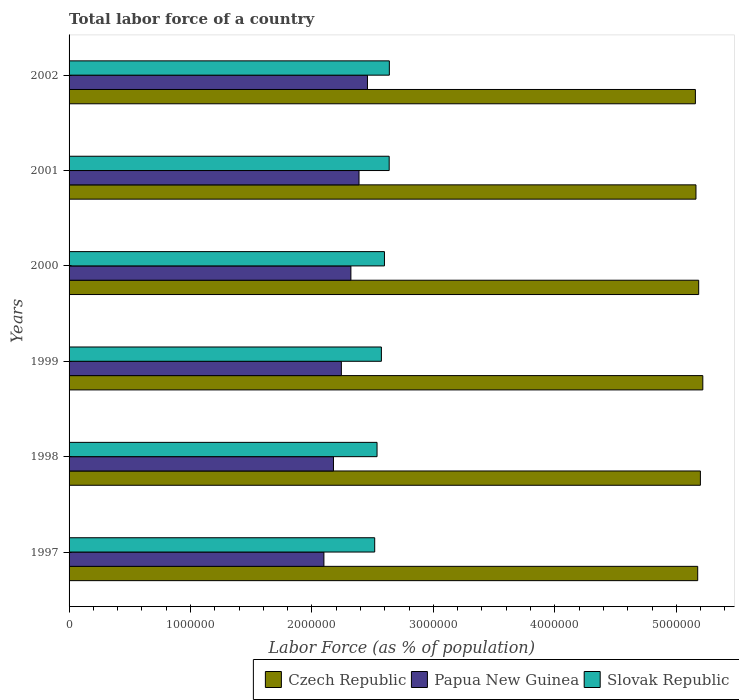How many groups of bars are there?
Offer a very short reply. 6. Are the number of bars per tick equal to the number of legend labels?
Your answer should be compact. Yes. How many bars are there on the 5th tick from the top?
Your answer should be very brief. 3. What is the label of the 1st group of bars from the top?
Give a very brief answer. 2002. What is the percentage of labor force in Czech Republic in 1997?
Provide a succinct answer. 5.18e+06. Across all years, what is the maximum percentage of labor force in Czech Republic?
Give a very brief answer. 5.22e+06. Across all years, what is the minimum percentage of labor force in Slovak Republic?
Give a very brief answer. 2.52e+06. In which year was the percentage of labor force in Papua New Guinea maximum?
Provide a succinct answer. 2002. What is the total percentage of labor force in Slovak Republic in the graph?
Offer a very short reply. 1.55e+07. What is the difference between the percentage of labor force in Slovak Republic in 2000 and that in 2001?
Make the answer very short. -3.89e+04. What is the difference between the percentage of labor force in Czech Republic in 1999 and the percentage of labor force in Papua New Guinea in 2002?
Your answer should be compact. 2.76e+06. What is the average percentage of labor force in Slovak Republic per year?
Make the answer very short. 2.58e+06. In the year 2001, what is the difference between the percentage of labor force in Papua New Guinea and percentage of labor force in Czech Republic?
Provide a short and direct response. -2.77e+06. What is the ratio of the percentage of labor force in Papua New Guinea in 1999 to that in 2001?
Make the answer very short. 0.94. Is the difference between the percentage of labor force in Papua New Guinea in 1997 and 2001 greater than the difference between the percentage of labor force in Czech Republic in 1997 and 2001?
Provide a short and direct response. No. What is the difference between the highest and the second highest percentage of labor force in Czech Republic?
Keep it short and to the point. 1.98e+04. What is the difference between the highest and the lowest percentage of labor force in Slovak Republic?
Make the answer very short. 1.21e+05. In how many years, is the percentage of labor force in Papua New Guinea greater than the average percentage of labor force in Papua New Guinea taken over all years?
Keep it short and to the point. 3. What does the 3rd bar from the top in 2001 represents?
Provide a succinct answer. Czech Republic. What does the 3rd bar from the bottom in 2001 represents?
Give a very brief answer. Slovak Republic. Are all the bars in the graph horizontal?
Ensure brevity in your answer.  Yes. Does the graph contain grids?
Your response must be concise. No. Where does the legend appear in the graph?
Keep it short and to the point. Bottom right. How many legend labels are there?
Your answer should be very brief. 3. What is the title of the graph?
Provide a succinct answer. Total labor force of a country. Does "Denmark" appear as one of the legend labels in the graph?
Your response must be concise. No. What is the label or title of the X-axis?
Your answer should be very brief. Labor Force (as % of population). What is the label or title of the Y-axis?
Your answer should be compact. Years. What is the Labor Force (as % of population) in Czech Republic in 1997?
Give a very brief answer. 5.18e+06. What is the Labor Force (as % of population) of Papua New Guinea in 1997?
Ensure brevity in your answer.  2.10e+06. What is the Labor Force (as % of population) of Slovak Republic in 1997?
Ensure brevity in your answer.  2.52e+06. What is the Labor Force (as % of population) of Czech Republic in 1998?
Your answer should be compact. 5.20e+06. What is the Labor Force (as % of population) in Papua New Guinea in 1998?
Your answer should be very brief. 2.18e+06. What is the Labor Force (as % of population) in Slovak Republic in 1998?
Ensure brevity in your answer.  2.54e+06. What is the Labor Force (as % of population) in Czech Republic in 1999?
Ensure brevity in your answer.  5.22e+06. What is the Labor Force (as % of population) of Papua New Guinea in 1999?
Make the answer very short. 2.24e+06. What is the Labor Force (as % of population) of Slovak Republic in 1999?
Provide a short and direct response. 2.57e+06. What is the Labor Force (as % of population) of Czech Republic in 2000?
Your response must be concise. 5.18e+06. What is the Labor Force (as % of population) in Papua New Guinea in 2000?
Your answer should be very brief. 2.32e+06. What is the Labor Force (as % of population) in Slovak Republic in 2000?
Your answer should be very brief. 2.60e+06. What is the Labor Force (as % of population) in Czech Republic in 2001?
Keep it short and to the point. 5.16e+06. What is the Labor Force (as % of population) in Papua New Guinea in 2001?
Provide a succinct answer. 2.39e+06. What is the Labor Force (as % of population) of Slovak Republic in 2001?
Offer a very short reply. 2.64e+06. What is the Labor Force (as % of population) in Czech Republic in 2002?
Offer a very short reply. 5.16e+06. What is the Labor Force (as % of population) in Papua New Guinea in 2002?
Offer a very short reply. 2.46e+06. What is the Labor Force (as % of population) in Slovak Republic in 2002?
Give a very brief answer. 2.64e+06. Across all years, what is the maximum Labor Force (as % of population) of Czech Republic?
Your answer should be compact. 5.22e+06. Across all years, what is the maximum Labor Force (as % of population) in Papua New Guinea?
Offer a terse response. 2.46e+06. Across all years, what is the maximum Labor Force (as % of population) in Slovak Republic?
Make the answer very short. 2.64e+06. Across all years, what is the minimum Labor Force (as % of population) of Czech Republic?
Your answer should be compact. 5.16e+06. Across all years, what is the minimum Labor Force (as % of population) in Papua New Guinea?
Offer a very short reply. 2.10e+06. Across all years, what is the minimum Labor Force (as % of population) of Slovak Republic?
Keep it short and to the point. 2.52e+06. What is the total Labor Force (as % of population) in Czech Republic in the graph?
Your response must be concise. 3.11e+07. What is the total Labor Force (as % of population) in Papua New Guinea in the graph?
Ensure brevity in your answer.  1.37e+07. What is the total Labor Force (as % of population) of Slovak Republic in the graph?
Offer a terse response. 1.55e+07. What is the difference between the Labor Force (as % of population) of Czech Republic in 1997 and that in 1998?
Your answer should be very brief. -2.22e+04. What is the difference between the Labor Force (as % of population) of Papua New Guinea in 1997 and that in 1998?
Provide a succinct answer. -7.87e+04. What is the difference between the Labor Force (as % of population) in Slovak Republic in 1997 and that in 1998?
Provide a short and direct response. -1.93e+04. What is the difference between the Labor Force (as % of population) in Czech Republic in 1997 and that in 1999?
Offer a terse response. -4.21e+04. What is the difference between the Labor Force (as % of population) of Papua New Guinea in 1997 and that in 1999?
Provide a short and direct response. -1.44e+05. What is the difference between the Labor Force (as % of population) of Slovak Republic in 1997 and that in 1999?
Provide a short and direct response. -5.51e+04. What is the difference between the Labor Force (as % of population) in Czech Republic in 1997 and that in 2000?
Ensure brevity in your answer.  -8125. What is the difference between the Labor Force (as % of population) of Papua New Guinea in 1997 and that in 2000?
Your answer should be very brief. -2.22e+05. What is the difference between the Labor Force (as % of population) of Slovak Republic in 1997 and that in 2000?
Your response must be concise. -8.04e+04. What is the difference between the Labor Force (as % of population) in Czech Republic in 1997 and that in 2001?
Ensure brevity in your answer.  1.42e+04. What is the difference between the Labor Force (as % of population) in Papua New Guinea in 1997 and that in 2001?
Make the answer very short. -2.89e+05. What is the difference between the Labor Force (as % of population) of Slovak Republic in 1997 and that in 2001?
Make the answer very short. -1.19e+05. What is the difference between the Labor Force (as % of population) in Czech Republic in 1997 and that in 2002?
Your answer should be compact. 1.90e+04. What is the difference between the Labor Force (as % of population) of Papua New Guinea in 1997 and that in 2002?
Provide a short and direct response. -3.59e+05. What is the difference between the Labor Force (as % of population) of Slovak Republic in 1997 and that in 2002?
Provide a succinct answer. -1.21e+05. What is the difference between the Labor Force (as % of population) in Czech Republic in 1998 and that in 1999?
Keep it short and to the point. -1.98e+04. What is the difference between the Labor Force (as % of population) of Papua New Guinea in 1998 and that in 1999?
Your response must be concise. -6.50e+04. What is the difference between the Labor Force (as % of population) in Slovak Republic in 1998 and that in 1999?
Offer a terse response. -3.58e+04. What is the difference between the Labor Force (as % of population) of Czech Republic in 1998 and that in 2000?
Give a very brief answer. 1.41e+04. What is the difference between the Labor Force (as % of population) in Papua New Guinea in 1998 and that in 2000?
Make the answer very short. -1.43e+05. What is the difference between the Labor Force (as % of population) in Slovak Republic in 1998 and that in 2000?
Ensure brevity in your answer.  -6.10e+04. What is the difference between the Labor Force (as % of population) of Czech Republic in 1998 and that in 2001?
Offer a terse response. 3.65e+04. What is the difference between the Labor Force (as % of population) in Papua New Guinea in 1998 and that in 2001?
Offer a terse response. -2.10e+05. What is the difference between the Labor Force (as % of population) in Slovak Republic in 1998 and that in 2001?
Your response must be concise. -9.99e+04. What is the difference between the Labor Force (as % of population) in Czech Republic in 1998 and that in 2002?
Give a very brief answer. 4.13e+04. What is the difference between the Labor Force (as % of population) in Papua New Guinea in 1998 and that in 2002?
Your answer should be compact. -2.80e+05. What is the difference between the Labor Force (as % of population) in Slovak Republic in 1998 and that in 2002?
Your response must be concise. -1.01e+05. What is the difference between the Labor Force (as % of population) in Czech Republic in 1999 and that in 2000?
Your answer should be compact. 3.39e+04. What is the difference between the Labor Force (as % of population) in Papua New Guinea in 1999 and that in 2000?
Provide a short and direct response. -7.85e+04. What is the difference between the Labor Force (as % of population) of Slovak Republic in 1999 and that in 2000?
Provide a short and direct response. -2.52e+04. What is the difference between the Labor Force (as % of population) of Czech Republic in 1999 and that in 2001?
Make the answer very short. 5.63e+04. What is the difference between the Labor Force (as % of population) in Papua New Guinea in 1999 and that in 2001?
Offer a very short reply. -1.45e+05. What is the difference between the Labor Force (as % of population) of Slovak Republic in 1999 and that in 2001?
Your response must be concise. -6.42e+04. What is the difference between the Labor Force (as % of population) in Czech Republic in 1999 and that in 2002?
Offer a very short reply. 6.11e+04. What is the difference between the Labor Force (as % of population) in Papua New Guinea in 1999 and that in 2002?
Make the answer very short. -2.15e+05. What is the difference between the Labor Force (as % of population) of Slovak Republic in 1999 and that in 2002?
Provide a succinct answer. -6.54e+04. What is the difference between the Labor Force (as % of population) of Czech Republic in 2000 and that in 2001?
Offer a very short reply. 2.24e+04. What is the difference between the Labor Force (as % of population) in Papua New Guinea in 2000 and that in 2001?
Keep it short and to the point. -6.69e+04. What is the difference between the Labor Force (as % of population) in Slovak Republic in 2000 and that in 2001?
Keep it short and to the point. -3.89e+04. What is the difference between the Labor Force (as % of population) in Czech Republic in 2000 and that in 2002?
Provide a succinct answer. 2.72e+04. What is the difference between the Labor Force (as % of population) of Papua New Guinea in 2000 and that in 2002?
Ensure brevity in your answer.  -1.36e+05. What is the difference between the Labor Force (as % of population) in Slovak Republic in 2000 and that in 2002?
Your answer should be compact. -4.02e+04. What is the difference between the Labor Force (as % of population) of Czech Republic in 2001 and that in 2002?
Offer a terse response. 4794. What is the difference between the Labor Force (as % of population) in Papua New Guinea in 2001 and that in 2002?
Your answer should be compact. -6.95e+04. What is the difference between the Labor Force (as % of population) in Slovak Republic in 2001 and that in 2002?
Provide a short and direct response. -1283. What is the difference between the Labor Force (as % of population) in Czech Republic in 1997 and the Labor Force (as % of population) in Papua New Guinea in 1998?
Provide a short and direct response. 3.00e+06. What is the difference between the Labor Force (as % of population) of Czech Republic in 1997 and the Labor Force (as % of population) of Slovak Republic in 1998?
Ensure brevity in your answer.  2.64e+06. What is the difference between the Labor Force (as % of population) in Papua New Guinea in 1997 and the Labor Force (as % of population) in Slovak Republic in 1998?
Offer a very short reply. -4.38e+05. What is the difference between the Labor Force (as % of population) in Czech Republic in 1997 and the Labor Force (as % of population) in Papua New Guinea in 1999?
Offer a terse response. 2.93e+06. What is the difference between the Labor Force (as % of population) of Czech Republic in 1997 and the Labor Force (as % of population) of Slovak Republic in 1999?
Keep it short and to the point. 2.60e+06. What is the difference between the Labor Force (as % of population) in Papua New Guinea in 1997 and the Labor Force (as % of population) in Slovak Republic in 1999?
Your response must be concise. -4.73e+05. What is the difference between the Labor Force (as % of population) in Czech Republic in 1997 and the Labor Force (as % of population) in Papua New Guinea in 2000?
Your answer should be compact. 2.86e+06. What is the difference between the Labor Force (as % of population) of Czech Republic in 1997 and the Labor Force (as % of population) of Slovak Republic in 2000?
Your response must be concise. 2.58e+06. What is the difference between the Labor Force (as % of population) in Papua New Guinea in 1997 and the Labor Force (as % of population) in Slovak Republic in 2000?
Your answer should be compact. -4.99e+05. What is the difference between the Labor Force (as % of population) in Czech Republic in 1997 and the Labor Force (as % of population) in Papua New Guinea in 2001?
Give a very brief answer. 2.79e+06. What is the difference between the Labor Force (as % of population) in Czech Republic in 1997 and the Labor Force (as % of population) in Slovak Republic in 2001?
Provide a succinct answer. 2.54e+06. What is the difference between the Labor Force (as % of population) of Papua New Guinea in 1997 and the Labor Force (as % of population) of Slovak Republic in 2001?
Keep it short and to the point. -5.37e+05. What is the difference between the Labor Force (as % of population) of Czech Republic in 1997 and the Labor Force (as % of population) of Papua New Guinea in 2002?
Offer a very short reply. 2.72e+06. What is the difference between the Labor Force (as % of population) in Czech Republic in 1997 and the Labor Force (as % of population) in Slovak Republic in 2002?
Give a very brief answer. 2.54e+06. What is the difference between the Labor Force (as % of population) in Papua New Guinea in 1997 and the Labor Force (as % of population) in Slovak Republic in 2002?
Ensure brevity in your answer.  -5.39e+05. What is the difference between the Labor Force (as % of population) in Czech Republic in 1998 and the Labor Force (as % of population) in Papua New Guinea in 1999?
Make the answer very short. 2.96e+06. What is the difference between the Labor Force (as % of population) of Czech Republic in 1998 and the Labor Force (as % of population) of Slovak Republic in 1999?
Provide a short and direct response. 2.63e+06. What is the difference between the Labor Force (as % of population) in Papua New Guinea in 1998 and the Labor Force (as % of population) in Slovak Republic in 1999?
Provide a succinct answer. -3.95e+05. What is the difference between the Labor Force (as % of population) of Czech Republic in 1998 and the Labor Force (as % of population) of Papua New Guinea in 2000?
Keep it short and to the point. 2.88e+06. What is the difference between the Labor Force (as % of population) of Czech Republic in 1998 and the Labor Force (as % of population) of Slovak Republic in 2000?
Make the answer very short. 2.60e+06. What is the difference between the Labor Force (as % of population) of Papua New Guinea in 1998 and the Labor Force (as % of population) of Slovak Republic in 2000?
Your answer should be compact. -4.20e+05. What is the difference between the Labor Force (as % of population) of Czech Republic in 1998 and the Labor Force (as % of population) of Papua New Guinea in 2001?
Ensure brevity in your answer.  2.81e+06. What is the difference between the Labor Force (as % of population) of Czech Republic in 1998 and the Labor Force (as % of population) of Slovak Republic in 2001?
Keep it short and to the point. 2.56e+06. What is the difference between the Labor Force (as % of population) of Papua New Guinea in 1998 and the Labor Force (as % of population) of Slovak Republic in 2001?
Keep it short and to the point. -4.59e+05. What is the difference between the Labor Force (as % of population) of Czech Republic in 1998 and the Labor Force (as % of population) of Papua New Guinea in 2002?
Provide a short and direct response. 2.74e+06. What is the difference between the Labor Force (as % of population) in Czech Republic in 1998 and the Labor Force (as % of population) in Slovak Republic in 2002?
Your answer should be compact. 2.56e+06. What is the difference between the Labor Force (as % of population) of Papua New Guinea in 1998 and the Labor Force (as % of population) of Slovak Republic in 2002?
Offer a very short reply. -4.60e+05. What is the difference between the Labor Force (as % of population) of Czech Republic in 1999 and the Labor Force (as % of population) of Papua New Guinea in 2000?
Your answer should be compact. 2.90e+06. What is the difference between the Labor Force (as % of population) in Czech Republic in 1999 and the Labor Force (as % of population) in Slovak Republic in 2000?
Your answer should be very brief. 2.62e+06. What is the difference between the Labor Force (as % of population) of Papua New Guinea in 1999 and the Labor Force (as % of population) of Slovak Republic in 2000?
Your answer should be compact. -3.55e+05. What is the difference between the Labor Force (as % of population) of Czech Republic in 1999 and the Labor Force (as % of population) of Papua New Guinea in 2001?
Your answer should be compact. 2.83e+06. What is the difference between the Labor Force (as % of population) in Czech Republic in 1999 and the Labor Force (as % of population) in Slovak Republic in 2001?
Ensure brevity in your answer.  2.58e+06. What is the difference between the Labor Force (as % of population) in Papua New Guinea in 1999 and the Labor Force (as % of population) in Slovak Republic in 2001?
Your answer should be very brief. -3.94e+05. What is the difference between the Labor Force (as % of population) in Czech Republic in 1999 and the Labor Force (as % of population) in Papua New Guinea in 2002?
Offer a terse response. 2.76e+06. What is the difference between the Labor Force (as % of population) in Czech Republic in 1999 and the Labor Force (as % of population) in Slovak Republic in 2002?
Your response must be concise. 2.58e+06. What is the difference between the Labor Force (as % of population) in Papua New Guinea in 1999 and the Labor Force (as % of population) in Slovak Republic in 2002?
Your answer should be compact. -3.95e+05. What is the difference between the Labor Force (as % of population) in Czech Republic in 2000 and the Labor Force (as % of population) in Papua New Guinea in 2001?
Provide a short and direct response. 2.80e+06. What is the difference between the Labor Force (as % of population) in Czech Republic in 2000 and the Labor Force (as % of population) in Slovak Republic in 2001?
Provide a short and direct response. 2.55e+06. What is the difference between the Labor Force (as % of population) in Papua New Guinea in 2000 and the Labor Force (as % of population) in Slovak Republic in 2001?
Give a very brief answer. -3.15e+05. What is the difference between the Labor Force (as % of population) in Czech Republic in 2000 and the Labor Force (as % of population) in Papua New Guinea in 2002?
Give a very brief answer. 2.73e+06. What is the difference between the Labor Force (as % of population) of Czech Republic in 2000 and the Labor Force (as % of population) of Slovak Republic in 2002?
Offer a very short reply. 2.55e+06. What is the difference between the Labor Force (as % of population) in Papua New Guinea in 2000 and the Labor Force (as % of population) in Slovak Republic in 2002?
Keep it short and to the point. -3.17e+05. What is the difference between the Labor Force (as % of population) of Czech Republic in 2001 and the Labor Force (as % of population) of Papua New Guinea in 2002?
Give a very brief answer. 2.70e+06. What is the difference between the Labor Force (as % of population) of Czech Republic in 2001 and the Labor Force (as % of population) of Slovak Republic in 2002?
Ensure brevity in your answer.  2.52e+06. What is the difference between the Labor Force (as % of population) in Papua New Guinea in 2001 and the Labor Force (as % of population) in Slovak Republic in 2002?
Keep it short and to the point. -2.50e+05. What is the average Labor Force (as % of population) of Czech Republic per year?
Your response must be concise. 5.18e+06. What is the average Labor Force (as % of population) of Papua New Guinea per year?
Keep it short and to the point. 2.28e+06. What is the average Labor Force (as % of population) in Slovak Republic per year?
Provide a succinct answer. 2.58e+06. In the year 1997, what is the difference between the Labor Force (as % of population) in Czech Republic and Labor Force (as % of population) in Papua New Guinea?
Your answer should be very brief. 3.08e+06. In the year 1997, what is the difference between the Labor Force (as % of population) in Czech Republic and Labor Force (as % of population) in Slovak Republic?
Offer a very short reply. 2.66e+06. In the year 1997, what is the difference between the Labor Force (as % of population) of Papua New Guinea and Labor Force (as % of population) of Slovak Republic?
Give a very brief answer. -4.18e+05. In the year 1998, what is the difference between the Labor Force (as % of population) of Czech Republic and Labor Force (as % of population) of Papua New Guinea?
Your response must be concise. 3.02e+06. In the year 1998, what is the difference between the Labor Force (as % of population) of Czech Republic and Labor Force (as % of population) of Slovak Republic?
Your answer should be compact. 2.66e+06. In the year 1998, what is the difference between the Labor Force (as % of population) in Papua New Guinea and Labor Force (as % of population) in Slovak Republic?
Your answer should be very brief. -3.59e+05. In the year 1999, what is the difference between the Labor Force (as % of population) in Czech Republic and Labor Force (as % of population) in Papua New Guinea?
Your answer should be compact. 2.98e+06. In the year 1999, what is the difference between the Labor Force (as % of population) in Czech Republic and Labor Force (as % of population) in Slovak Republic?
Provide a short and direct response. 2.65e+06. In the year 1999, what is the difference between the Labor Force (as % of population) of Papua New Guinea and Labor Force (as % of population) of Slovak Republic?
Ensure brevity in your answer.  -3.30e+05. In the year 2000, what is the difference between the Labor Force (as % of population) in Czech Republic and Labor Force (as % of population) in Papua New Guinea?
Offer a very short reply. 2.86e+06. In the year 2000, what is the difference between the Labor Force (as % of population) of Czech Republic and Labor Force (as % of population) of Slovak Republic?
Offer a very short reply. 2.59e+06. In the year 2000, what is the difference between the Labor Force (as % of population) of Papua New Guinea and Labor Force (as % of population) of Slovak Republic?
Make the answer very short. -2.76e+05. In the year 2001, what is the difference between the Labor Force (as % of population) in Czech Republic and Labor Force (as % of population) in Papua New Guinea?
Your response must be concise. 2.77e+06. In the year 2001, what is the difference between the Labor Force (as % of population) of Czech Republic and Labor Force (as % of population) of Slovak Republic?
Your response must be concise. 2.53e+06. In the year 2001, what is the difference between the Labor Force (as % of population) of Papua New Guinea and Labor Force (as % of population) of Slovak Republic?
Give a very brief answer. -2.48e+05. In the year 2002, what is the difference between the Labor Force (as % of population) of Czech Republic and Labor Force (as % of population) of Papua New Guinea?
Provide a short and direct response. 2.70e+06. In the year 2002, what is the difference between the Labor Force (as % of population) of Czech Republic and Labor Force (as % of population) of Slovak Republic?
Keep it short and to the point. 2.52e+06. In the year 2002, what is the difference between the Labor Force (as % of population) in Papua New Guinea and Labor Force (as % of population) in Slovak Republic?
Give a very brief answer. -1.80e+05. What is the ratio of the Labor Force (as % of population) in Papua New Guinea in 1997 to that in 1998?
Give a very brief answer. 0.96. What is the ratio of the Labor Force (as % of population) of Slovak Republic in 1997 to that in 1998?
Provide a short and direct response. 0.99. What is the ratio of the Labor Force (as % of population) in Papua New Guinea in 1997 to that in 1999?
Make the answer very short. 0.94. What is the ratio of the Labor Force (as % of population) in Slovak Republic in 1997 to that in 1999?
Give a very brief answer. 0.98. What is the ratio of the Labor Force (as % of population) in Papua New Guinea in 1997 to that in 2000?
Keep it short and to the point. 0.9. What is the ratio of the Labor Force (as % of population) in Slovak Republic in 1997 to that in 2000?
Your response must be concise. 0.97. What is the ratio of the Labor Force (as % of population) of Papua New Guinea in 1997 to that in 2001?
Ensure brevity in your answer.  0.88. What is the ratio of the Labor Force (as % of population) in Slovak Republic in 1997 to that in 2001?
Make the answer very short. 0.95. What is the ratio of the Labor Force (as % of population) of Czech Republic in 1997 to that in 2002?
Provide a succinct answer. 1. What is the ratio of the Labor Force (as % of population) of Papua New Guinea in 1997 to that in 2002?
Your response must be concise. 0.85. What is the ratio of the Labor Force (as % of population) in Slovak Republic in 1997 to that in 2002?
Your response must be concise. 0.95. What is the ratio of the Labor Force (as % of population) in Czech Republic in 1998 to that in 1999?
Your response must be concise. 1. What is the ratio of the Labor Force (as % of population) of Papua New Guinea in 1998 to that in 1999?
Your answer should be compact. 0.97. What is the ratio of the Labor Force (as % of population) of Slovak Republic in 1998 to that in 1999?
Offer a very short reply. 0.99. What is the ratio of the Labor Force (as % of population) of Czech Republic in 1998 to that in 2000?
Keep it short and to the point. 1. What is the ratio of the Labor Force (as % of population) of Papua New Guinea in 1998 to that in 2000?
Keep it short and to the point. 0.94. What is the ratio of the Labor Force (as % of population) of Slovak Republic in 1998 to that in 2000?
Offer a terse response. 0.98. What is the ratio of the Labor Force (as % of population) in Czech Republic in 1998 to that in 2001?
Keep it short and to the point. 1.01. What is the ratio of the Labor Force (as % of population) in Papua New Guinea in 1998 to that in 2001?
Your response must be concise. 0.91. What is the ratio of the Labor Force (as % of population) in Slovak Republic in 1998 to that in 2001?
Keep it short and to the point. 0.96. What is the ratio of the Labor Force (as % of population) of Czech Republic in 1998 to that in 2002?
Offer a very short reply. 1.01. What is the ratio of the Labor Force (as % of population) in Papua New Guinea in 1998 to that in 2002?
Provide a succinct answer. 0.89. What is the ratio of the Labor Force (as % of population) of Slovak Republic in 1998 to that in 2002?
Make the answer very short. 0.96. What is the ratio of the Labor Force (as % of population) of Czech Republic in 1999 to that in 2000?
Give a very brief answer. 1.01. What is the ratio of the Labor Force (as % of population) of Papua New Guinea in 1999 to that in 2000?
Your answer should be very brief. 0.97. What is the ratio of the Labor Force (as % of population) of Slovak Republic in 1999 to that in 2000?
Ensure brevity in your answer.  0.99. What is the ratio of the Labor Force (as % of population) in Czech Republic in 1999 to that in 2001?
Your answer should be compact. 1.01. What is the ratio of the Labor Force (as % of population) of Papua New Guinea in 1999 to that in 2001?
Your answer should be very brief. 0.94. What is the ratio of the Labor Force (as % of population) of Slovak Republic in 1999 to that in 2001?
Give a very brief answer. 0.98. What is the ratio of the Labor Force (as % of population) in Czech Republic in 1999 to that in 2002?
Offer a very short reply. 1.01. What is the ratio of the Labor Force (as % of population) in Papua New Guinea in 1999 to that in 2002?
Offer a terse response. 0.91. What is the ratio of the Labor Force (as % of population) in Slovak Republic in 1999 to that in 2002?
Your answer should be compact. 0.98. What is the ratio of the Labor Force (as % of population) in Slovak Republic in 2000 to that in 2001?
Give a very brief answer. 0.99. What is the ratio of the Labor Force (as % of population) of Czech Republic in 2000 to that in 2002?
Your response must be concise. 1.01. What is the ratio of the Labor Force (as % of population) in Papua New Guinea in 2000 to that in 2002?
Ensure brevity in your answer.  0.94. What is the ratio of the Labor Force (as % of population) in Slovak Republic in 2000 to that in 2002?
Ensure brevity in your answer.  0.98. What is the ratio of the Labor Force (as % of population) in Papua New Guinea in 2001 to that in 2002?
Ensure brevity in your answer.  0.97. What is the ratio of the Labor Force (as % of population) in Slovak Republic in 2001 to that in 2002?
Offer a terse response. 1. What is the difference between the highest and the second highest Labor Force (as % of population) in Czech Republic?
Your answer should be compact. 1.98e+04. What is the difference between the highest and the second highest Labor Force (as % of population) in Papua New Guinea?
Offer a very short reply. 6.95e+04. What is the difference between the highest and the second highest Labor Force (as % of population) of Slovak Republic?
Your response must be concise. 1283. What is the difference between the highest and the lowest Labor Force (as % of population) of Czech Republic?
Offer a very short reply. 6.11e+04. What is the difference between the highest and the lowest Labor Force (as % of population) of Papua New Guinea?
Make the answer very short. 3.59e+05. What is the difference between the highest and the lowest Labor Force (as % of population) of Slovak Republic?
Offer a terse response. 1.21e+05. 